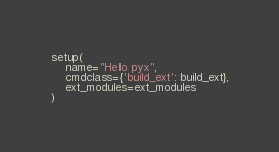Convert code to text. <code><loc_0><loc_0><loc_500><loc_500><_Python_>setup(
    name="Hello pyx",
    cmdclass={'build_ext': build_ext},
    ext_modules=ext_modules
)
</code> 